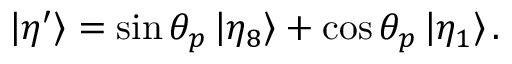<formula> <loc_0><loc_0><loc_500><loc_500>\left | \eta ^ { \prime } \right \rangle = \sin \theta _ { p } \left | \eta _ { 8 } \right \rangle + \cos \theta _ { p } \left | \eta _ { 1 } \right \rangle .</formula> 